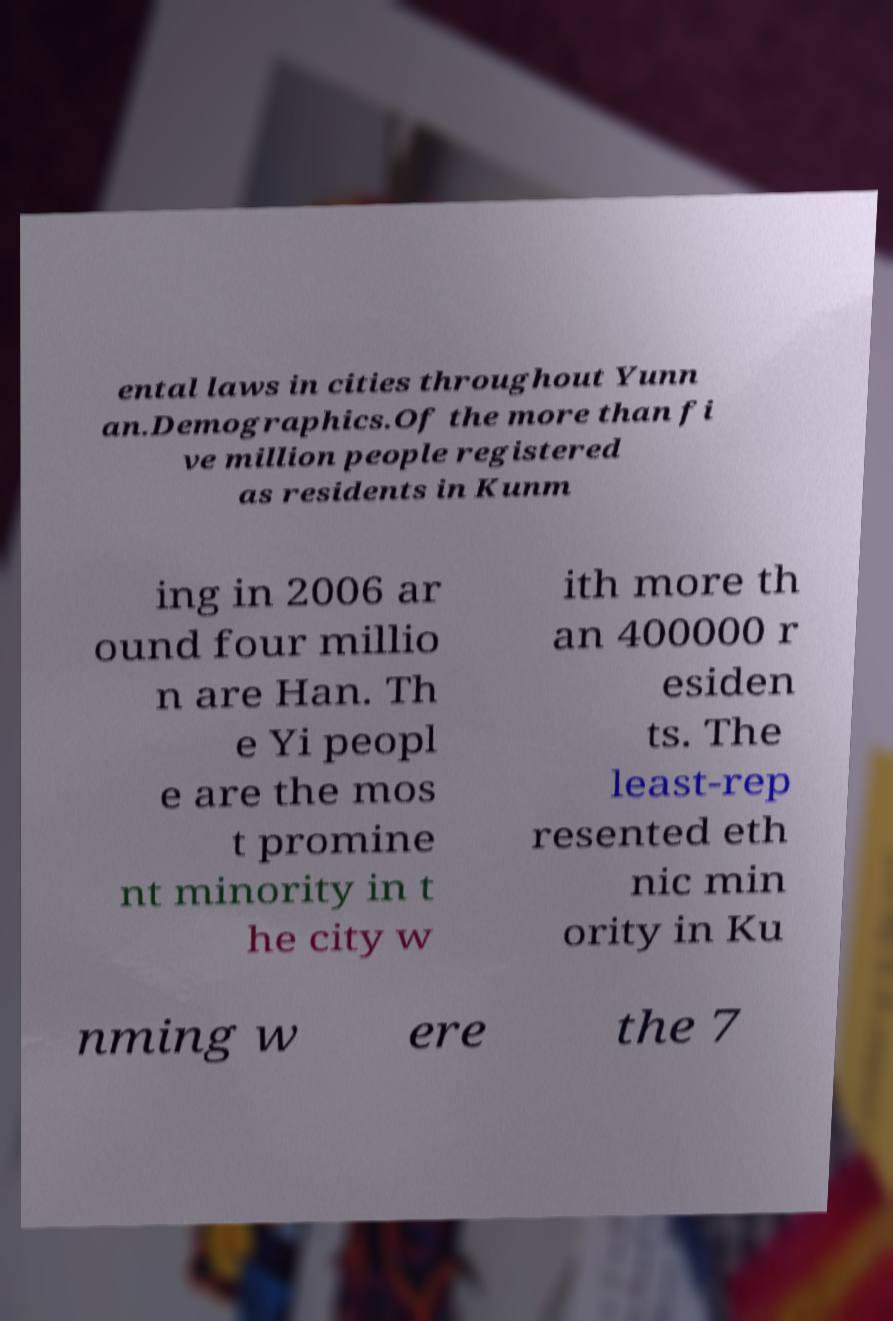There's text embedded in this image that I need extracted. Can you transcribe it verbatim? ental laws in cities throughout Yunn an.Demographics.Of the more than fi ve million people registered as residents in Kunm ing in 2006 ar ound four millio n are Han. Th e Yi peopl e are the mos t promine nt minority in t he city w ith more th an 400000 r esiden ts. The least-rep resented eth nic min ority in Ku nming w ere the 7 